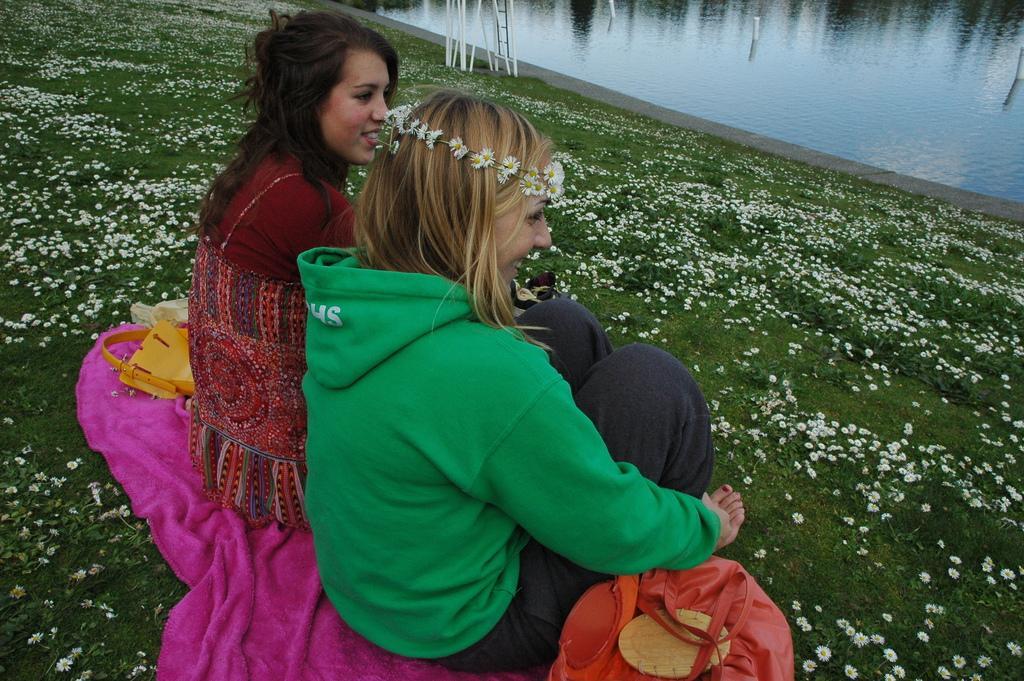How would you summarize this image in a sentence or two? In the foreground of the picture there are two women, cloth, handbags, grass and flowers. At the top there is a water body. 